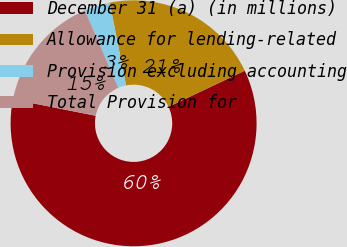<chart> <loc_0><loc_0><loc_500><loc_500><pie_chart><fcel>December 31 (a) (in millions)<fcel>Allowance for lending-related<fcel>Provision excluding accounting<fcel>Total Provision for<nl><fcel>60.15%<fcel>21.08%<fcel>3.36%<fcel>15.4%<nl></chart> 